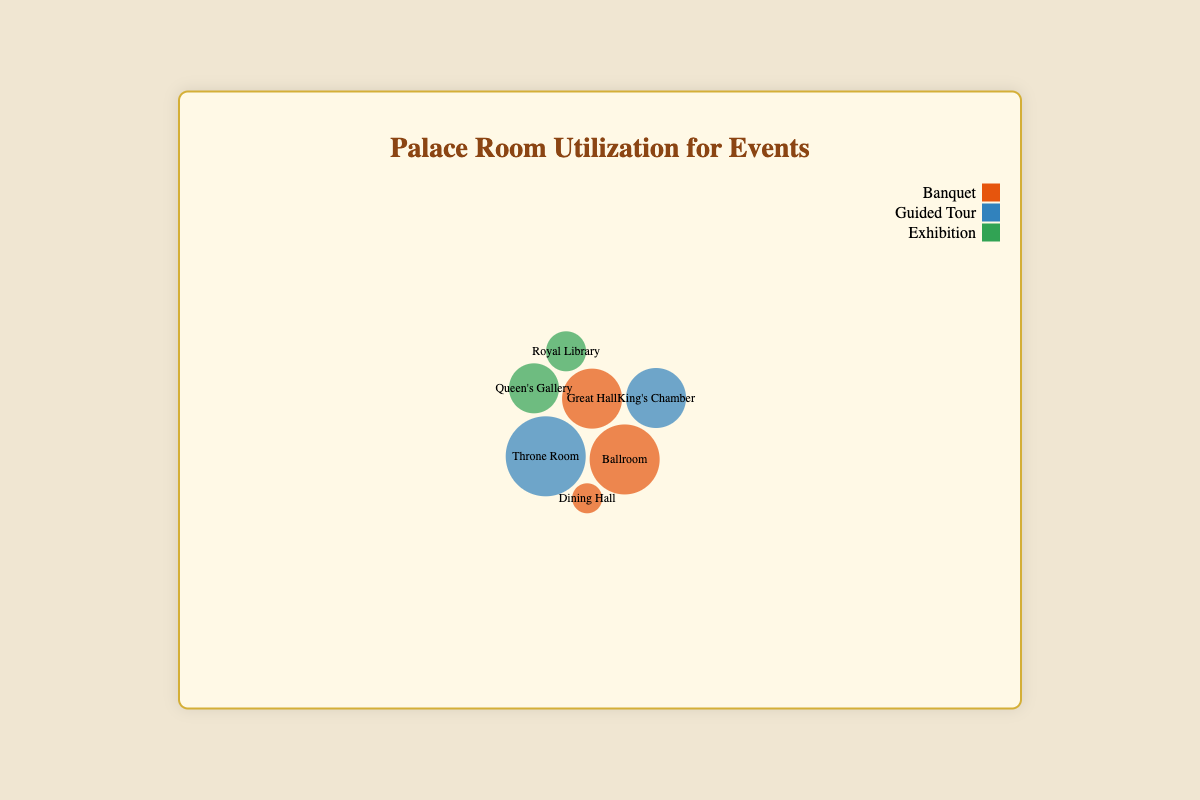what's the title of the chart? The title of the chart is usually displayed prominently at the top and is designed to convey the main topic or purpose of the visualization. In this case, the title “Palace Room Utilization for Events” is centralized at the top of the figure.
Answer: Palace Room Utilization for Events how many rooms are displayed for event utilization? Each room is represented by a bubble on the chart. Count the number of distinct bubbles to determine the variety of rooms used for events. There are 7 different rooms illustrated in the bubble chart.
Answer: 7 which event type has the highest frequency in the Throne Room? Locate the bubble for the Throne Room and check the color or legend that indicates the type of event it represents. The color corresponding to "Guided Tour" indicates that this is the event type with the highest frequency in the Throne Room, with a frequency of 40.
Answer: Guided Tour how does the size of the bubble for Banquets in the Ballroom compare to that in the Great Hall? Compare the radii (given as sizes) of the bubbles. The radius for the Banquet in the Ballroom is 35, while in the Great Hall, it is 30. This indicates that the Banquet bubble in the Ballroom is larger.
Answer: Ballroom's bubble is larger which room is most frequently used for Exhibitions? Look at the bubbles associated with the event type “Exhibition” and compare their frequencies. The Royal Library and Queen's Gallery are used for Exhibitions, with frequencies of 15 and 20, respectively. Thus, Queen's Gallery is the most frequently used room for Exhibitions.
Answer: Queen's Gallery what is the total frequency of Banquets in all rooms combined? Sum up the frequencies for the event type “Banquet” across the rooms: Great Hall (25), Ballroom (30), and Dining Hall (10). The steps are 25 + 30 + 10.
Answer: 65 is the King's Chamber or the Throne Room more frequently used for Guided Tours? Compare the frequencies of Guided Tours in King's Chamber and Throne Room. The frequency for King's Chamber is 35, while it is 40 for the Throne Room. Therefore, the Throne Room is used more frequently for Guided Tours.
Answer: Throne Room what is the difference in frequencies between the largest and smallest bubbles? Identify the largest and smallest bubbles by their frequencies. The largest, Throne Room (40), and the smallest, Dining Hall (10). Calculating the difference: 40 - 10.
Answer: 30 which event type is utilized least in the entire palace based on frequency? Sum the frequencies of all event types and compare: Banquets (25+30+10=65), Guided Tours (40+35=75), Exhibitions (15+20=35). Exhibitions have the lowest total frequency.
Answer: Exhibitions what is the radius of the bubble for Banquets in the Great Hall? Find the bubble labeled with the Great Hall and the event type Banquet. The radius is provided directly, which is 30.
Answer: 30 